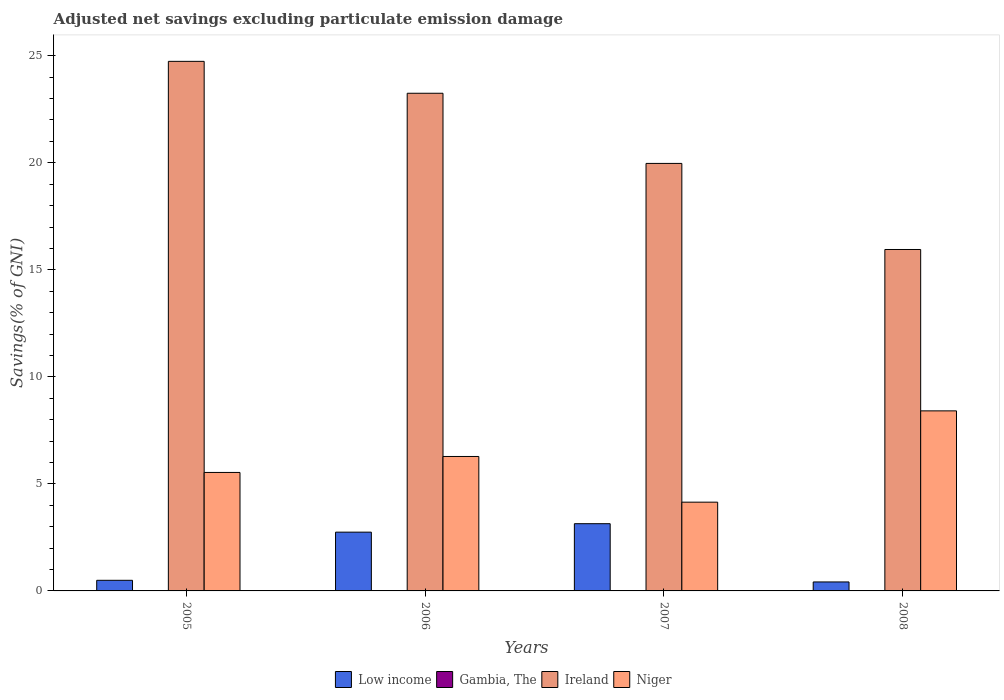How many different coloured bars are there?
Your answer should be very brief. 3. How many groups of bars are there?
Offer a terse response. 4. How many bars are there on the 4th tick from the left?
Make the answer very short. 3. How many bars are there on the 3rd tick from the right?
Give a very brief answer. 3. In how many cases, is the number of bars for a given year not equal to the number of legend labels?
Ensure brevity in your answer.  4. What is the adjusted net savings in Gambia, The in 2005?
Provide a short and direct response. 0. Across all years, what is the maximum adjusted net savings in Low income?
Provide a succinct answer. 3.14. Across all years, what is the minimum adjusted net savings in Ireland?
Your response must be concise. 15.95. In which year was the adjusted net savings in Ireland maximum?
Your response must be concise. 2005. What is the difference between the adjusted net savings in Ireland in 2005 and that in 2007?
Provide a short and direct response. 4.77. What is the difference between the adjusted net savings in Ireland in 2005 and the adjusted net savings in Niger in 2006?
Give a very brief answer. 18.46. What is the average adjusted net savings in Niger per year?
Give a very brief answer. 6.09. In the year 2008, what is the difference between the adjusted net savings in Ireland and adjusted net savings in Niger?
Offer a terse response. 7.54. In how many years, is the adjusted net savings in Niger greater than 14 %?
Your answer should be very brief. 0. What is the ratio of the adjusted net savings in Ireland in 2005 to that in 2006?
Your answer should be very brief. 1.06. Is the difference between the adjusted net savings in Ireland in 2006 and 2008 greater than the difference between the adjusted net savings in Niger in 2006 and 2008?
Provide a short and direct response. Yes. What is the difference between the highest and the second highest adjusted net savings in Ireland?
Keep it short and to the point. 1.49. What is the difference between the highest and the lowest adjusted net savings in Niger?
Give a very brief answer. 4.26. In how many years, is the adjusted net savings in Ireland greater than the average adjusted net savings in Ireland taken over all years?
Offer a very short reply. 2. Is the sum of the adjusted net savings in Low income in 2005 and 2006 greater than the maximum adjusted net savings in Ireland across all years?
Provide a succinct answer. No. Is it the case that in every year, the sum of the adjusted net savings in Low income and adjusted net savings in Gambia, The is greater than the adjusted net savings in Ireland?
Your answer should be very brief. No. Are all the bars in the graph horizontal?
Your answer should be very brief. No. How many years are there in the graph?
Give a very brief answer. 4. What is the difference between two consecutive major ticks on the Y-axis?
Ensure brevity in your answer.  5. Are the values on the major ticks of Y-axis written in scientific E-notation?
Make the answer very short. No. Does the graph contain any zero values?
Provide a succinct answer. Yes. How many legend labels are there?
Your answer should be compact. 4. What is the title of the graph?
Ensure brevity in your answer.  Adjusted net savings excluding particulate emission damage. Does "Belgium" appear as one of the legend labels in the graph?
Provide a succinct answer. No. What is the label or title of the X-axis?
Your answer should be compact. Years. What is the label or title of the Y-axis?
Give a very brief answer. Savings(% of GNI). What is the Savings(% of GNI) in Low income in 2005?
Provide a short and direct response. 0.5. What is the Savings(% of GNI) of Ireland in 2005?
Your response must be concise. 24.74. What is the Savings(% of GNI) of Niger in 2005?
Make the answer very short. 5.53. What is the Savings(% of GNI) of Low income in 2006?
Your answer should be very brief. 2.75. What is the Savings(% of GNI) of Gambia, The in 2006?
Ensure brevity in your answer.  0. What is the Savings(% of GNI) in Ireland in 2006?
Offer a very short reply. 23.25. What is the Savings(% of GNI) of Niger in 2006?
Your answer should be compact. 6.28. What is the Savings(% of GNI) in Low income in 2007?
Provide a succinct answer. 3.14. What is the Savings(% of GNI) in Gambia, The in 2007?
Provide a succinct answer. 0. What is the Savings(% of GNI) of Ireland in 2007?
Provide a succinct answer. 19.97. What is the Savings(% of GNI) of Niger in 2007?
Give a very brief answer. 4.15. What is the Savings(% of GNI) of Low income in 2008?
Make the answer very short. 0.42. What is the Savings(% of GNI) in Ireland in 2008?
Keep it short and to the point. 15.95. What is the Savings(% of GNI) in Niger in 2008?
Ensure brevity in your answer.  8.41. Across all years, what is the maximum Savings(% of GNI) in Low income?
Provide a short and direct response. 3.14. Across all years, what is the maximum Savings(% of GNI) in Ireland?
Your answer should be compact. 24.74. Across all years, what is the maximum Savings(% of GNI) of Niger?
Keep it short and to the point. 8.41. Across all years, what is the minimum Savings(% of GNI) in Low income?
Offer a very short reply. 0.42. Across all years, what is the minimum Savings(% of GNI) in Ireland?
Your response must be concise. 15.95. Across all years, what is the minimum Savings(% of GNI) in Niger?
Your answer should be very brief. 4.15. What is the total Savings(% of GNI) in Low income in the graph?
Keep it short and to the point. 6.8. What is the total Savings(% of GNI) of Ireland in the graph?
Your response must be concise. 83.91. What is the total Savings(% of GNI) in Niger in the graph?
Ensure brevity in your answer.  24.37. What is the difference between the Savings(% of GNI) of Low income in 2005 and that in 2006?
Provide a short and direct response. -2.25. What is the difference between the Savings(% of GNI) in Ireland in 2005 and that in 2006?
Your answer should be compact. 1.49. What is the difference between the Savings(% of GNI) in Niger in 2005 and that in 2006?
Give a very brief answer. -0.75. What is the difference between the Savings(% of GNI) of Low income in 2005 and that in 2007?
Give a very brief answer. -2.64. What is the difference between the Savings(% of GNI) of Ireland in 2005 and that in 2007?
Your answer should be compact. 4.77. What is the difference between the Savings(% of GNI) of Niger in 2005 and that in 2007?
Ensure brevity in your answer.  1.39. What is the difference between the Savings(% of GNI) of Low income in 2005 and that in 2008?
Give a very brief answer. 0.08. What is the difference between the Savings(% of GNI) of Ireland in 2005 and that in 2008?
Your answer should be very brief. 8.79. What is the difference between the Savings(% of GNI) in Niger in 2005 and that in 2008?
Ensure brevity in your answer.  -2.88. What is the difference between the Savings(% of GNI) in Low income in 2006 and that in 2007?
Provide a short and direct response. -0.4. What is the difference between the Savings(% of GNI) in Ireland in 2006 and that in 2007?
Offer a terse response. 3.28. What is the difference between the Savings(% of GNI) in Niger in 2006 and that in 2007?
Offer a very short reply. 2.13. What is the difference between the Savings(% of GNI) in Low income in 2006 and that in 2008?
Your answer should be compact. 2.33. What is the difference between the Savings(% of GNI) of Ireland in 2006 and that in 2008?
Your answer should be compact. 7.3. What is the difference between the Savings(% of GNI) in Niger in 2006 and that in 2008?
Provide a short and direct response. -2.13. What is the difference between the Savings(% of GNI) in Low income in 2007 and that in 2008?
Give a very brief answer. 2.72. What is the difference between the Savings(% of GNI) of Ireland in 2007 and that in 2008?
Your answer should be compact. 4.02. What is the difference between the Savings(% of GNI) of Niger in 2007 and that in 2008?
Your answer should be compact. -4.26. What is the difference between the Savings(% of GNI) in Low income in 2005 and the Savings(% of GNI) in Ireland in 2006?
Your answer should be compact. -22.75. What is the difference between the Savings(% of GNI) in Low income in 2005 and the Savings(% of GNI) in Niger in 2006?
Your answer should be very brief. -5.78. What is the difference between the Savings(% of GNI) in Ireland in 2005 and the Savings(% of GNI) in Niger in 2006?
Your response must be concise. 18.46. What is the difference between the Savings(% of GNI) in Low income in 2005 and the Savings(% of GNI) in Ireland in 2007?
Make the answer very short. -19.48. What is the difference between the Savings(% of GNI) of Low income in 2005 and the Savings(% of GNI) of Niger in 2007?
Offer a very short reply. -3.65. What is the difference between the Savings(% of GNI) in Ireland in 2005 and the Savings(% of GNI) in Niger in 2007?
Your response must be concise. 20.59. What is the difference between the Savings(% of GNI) in Low income in 2005 and the Savings(% of GNI) in Ireland in 2008?
Offer a terse response. -15.45. What is the difference between the Savings(% of GNI) in Low income in 2005 and the Savings(% of GNI) in Niger in 2008?
Provide a short and direct response. -7.92. What is the difference between the Savings(% of GNI) of Ireland in 2005 and the Savings(% of GNI) of Niger in 2008?
Give a very brief answer. 16.33. What is the difference between the Savings(% of GNI) of Low income in 2006 and the Savings(% of GNI) of Ireland in 2007?
Offer a terse response. -17.23. What is the difference between the Savings(% of GNI) of Low income in 2006 and the Savings(% of GNI) of Niger in 2007?
Keep it short and to the point. -1.4. What is the difference between the Savings(% of GNI) of Ireland in 2006 and the Savings(% of GNI) of Niger in 2007?
Ensure brevity in your answer.  19.1. What is the difference between the Savings(% of GNI) of Low income in 2006 and the Savings(% of GNI) of Ireland in 2008?
Offer a terse response. -13.2. What is the difference between the Savings(% of GNI) of Low income in 2006 and the Savings(% of GNI) of Niger in 2008?
Your answer should be very brief. -5.67. What is the difference between the Savings(% of GNI) in Ireland in 2006 and the Savings(% of GNI) in Niger in 2008?
Your answer should be very brief. 14.84. What is the difference between the Savings(% of GNI) in Low income in 2007 and the Savings(% of GNI) in Ireland in 2008?
Offer a very short reply. -12.81. What is the difference between the Savings(% of GNI) of Low income in 2007 and the Savings(% of GNI) of Niger in 2008?
Your answer should be compact. -5.27. What is the difference between the Savings(% of GNI) in Ireland in 2007 and the Savings(% of GNI) in Niger in 2008?
Offer a terse response. 11.56. What is the average Savings(% of GNI) in Low income per year?
Provide a succinct answer. 1.7. What is the average Savings(% of GNI) of Ireland per year?
Provide a short and direct response. 20.98. What is the average Savings(% of GNI) of Niger per year?
Provide a succinct answer. 6.09. In the year 2005, what is the difference between the Savings(% of GNI) of Low income and Savings(% of GNI) of Ireland?
Provide a succinct answer. -24.24. In the year 2005, what is the difference between the Savings(% of GNI) in Low income and Savings(% of GNI) in Niger?
Your answer should be compact. -5.04. In the year 2005, what is the difference between the Savings(% of GNI) in Ireland and Savings(% of GNI) in Niger?
Offer a terse response. 19.21. In the year 2006, what is the difference between the Savings(% of GNI) of Low income and Savings(% of GNI) of Ireland?
Your answer should be very brief. -20.5. In the year 2006, what is the difference between the Savings(% of GNI) in Low income and Savings(% of GNI) in Niger?
Keep it short and to the point. -3.54. In the year 2006, what is the difference between the Savings(% of GNI) in Ireland and Savings(% of GNI) in Niger?
Provide a succinct answer. 16.97. In the year 2007, what is the difference between the Savings(% of GNI) of Low income and Savings(% of GNI) of Ireland?
Give a very brief answer. -16.83. In the year 2007, what is the difference between the Savings(% of GNI) of Low income and Savings(% of GNI) of Niger?
Your response must be concise. -1.01. In the year 2007, what is the difference between the Savings(% of GNI) of Ireland and Savings(% of GNI) of Niger?
Keep it short and to the point. 15.83. In the year 2008, what is the difference between the Savings(% of GNI) of Low income and Savings(% of GNI) of Ireland?
Provide a short and direct response. -15.53. In the year 2008, what is the difference between the Savings(% of GNI) of Low income and Savings(% of GNI) of Niger?
Your answer should be compact. -7.99. In the year 2008, what is the difference between the Savings(% of GNI) in Ireland and Savings(% of GNI) in Niger?
Provide a succinct answer. 7.54. What is the ratio of the Savings(% of GNI) of Low income in 2005 to that in 2006?
Give a very brief answer. 0.18. What is the ratio of the Savings(% of GNI) of Ireland in 2005 to that in 2006?
Make the answer very short. 1.06. What is the ratio of the Savings(% of GNI) of Niger in 2005 to that in 2006?
Keep it short and to the point. 0.88. What is the ratio of the Savings(% of GNI) of Low income in 2005 to that in 2007?
Give a very brief answer. 0.16. What is the ratio of the Savings(% of GNI) in Ireland in 2005 to that in 2007?
Your answer should be very brief. 1.24. What is the ratio of the Savings(% of GNI) of Niger in 2005 to that in 2007?
Your answer should be very brief. 1.33. What is the ratio of the Savings(% of GNI) in Low income in 2005 to that in 2008?
Give a very brief answer. 1.18. What is the ratio of the Savings(% of GNI) of Ireland in 2005 to that in 2008?
Offer a very short reply. 1.55. What is the ratio of the Savings(% of GNI) of Niger in 2005 to that in 2008?
Provide a succinct answer. 0.66. What is the ratio of the Savings(% of GNI) of Low income in 2006 to that in 2007?
Keep it short and to the point. 0.87. What is the ratio of the Savings(% of GNI) of Ireland in 2006 to that in 2007?
Your answer should be compact. 1.16. What is the ratio of the Savings(% of GNI) of Niger in 2006 to that in 2007?
Provide a short and direct response. 1.51. What is the ratio of the Savings(% of GNI) in Low income in 2006 to that in 2008?
Give a very brief answer. 6.55. What is the ratio of the Savings(% of GNI) in Ireland in 2006 to that in 2008?
Provide a succinct answer. 1.46. What is the ratio of the Savings(% of GNI) in Niger in 2006 to that in 2008?
Offer a very short reply. 0.75. What is the ratio of the Savings(% of GNI) in Low income in 2007 to that in 2008?
Your answer should be very brief. 7.49. What is the ratio of the Savings(% of GNI) of Ireland in 2007 to that in 2008?
Your answer should be very brief. 1.25. What is the ratio of the Savings(% of GNI) in Niger in 2007 to that in 2008?
Your answer should be very brief. 0.49. What is the difference between the highest and the second highest Savings(% of GNI) in Low income?
Give a very brief answer. 0.4. What is the difference between the highest and the second highest Savings(% of GNI) of Ireland?
Keep it short and to the point. 1.49. What is the difference between the highest and the second highest Savings(% of GNI) in Niger?
Your answer should be very brief. 2.13. What is the difference between the highest and the lowest Savings(% of GNI) of Low income?
Give a very brief answer. 2.72. What is the difference between the highest and the lowest Savings(% of GNI) of Ireland?
Give a very brief answer. 8.79. What is the difference between the highest and the lowest Savings(% of GNI) of Niger?
Ensure brevity in your answer.  4.26. 